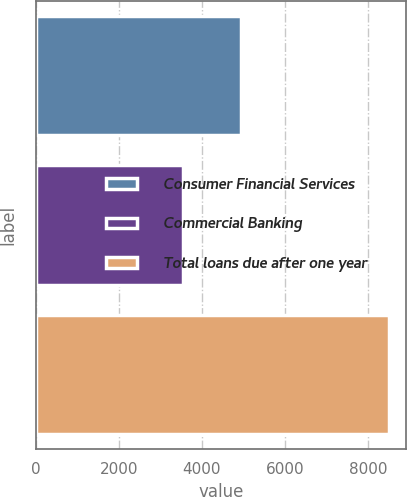Convert chart to OTSL. <chart><loc_0><loc_0><loc_500><loc_500><bar_chart><fcel>Consumer Financial Services<fcel>Commercial Banking<fcel>Total loans due after one year<nl><fcel>4948.8<fcel>3545.8<fcel>8494.6<nl></chart> 